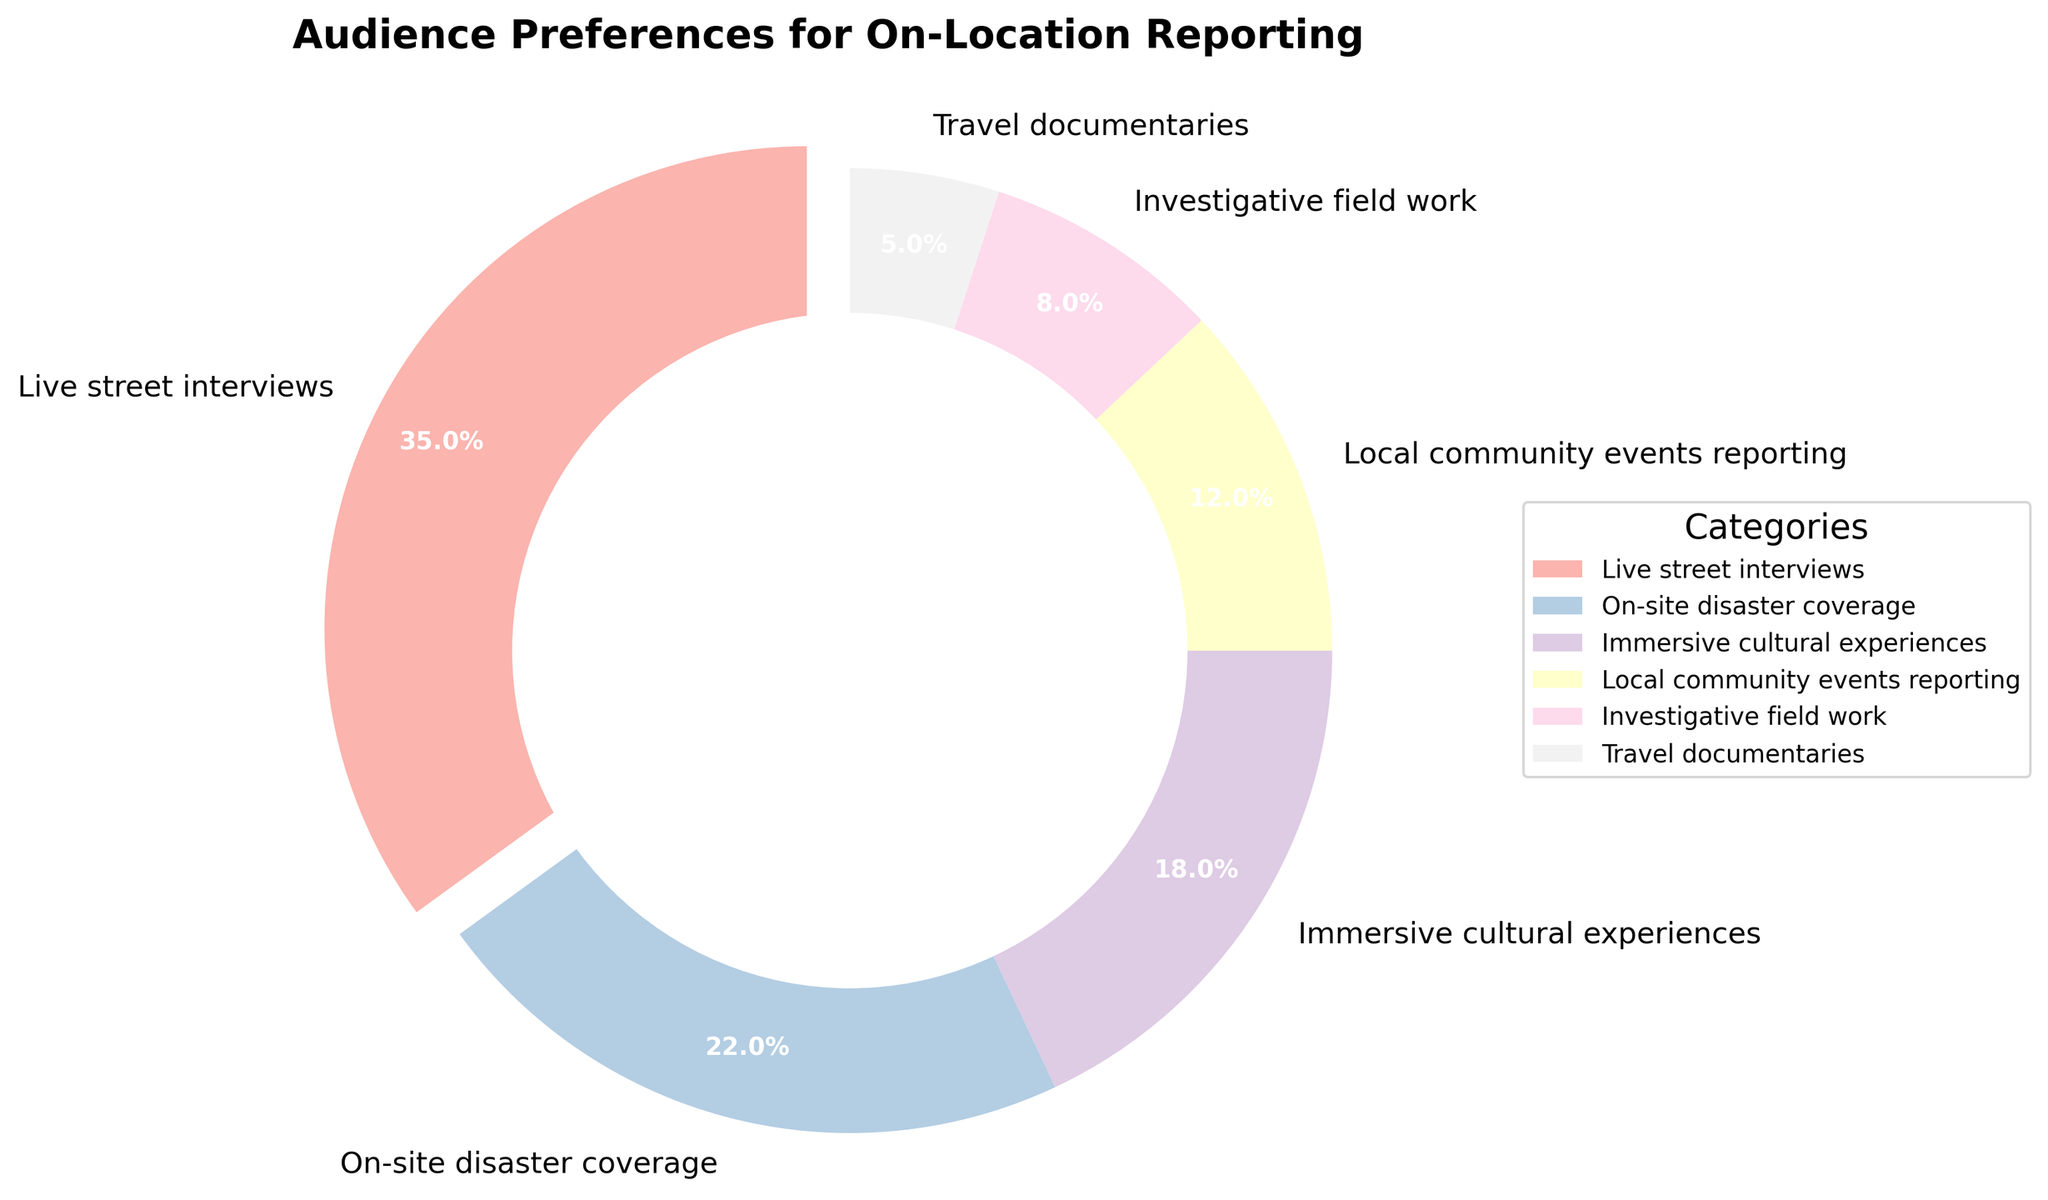Which category has the highest audience preference? The largest segment in the pie chart is the one denoted by the boldest wedge, which represents "Live street interviews." The percentage label also confirms that this category has 35%.
Answer: Live street interviews Which two categories together constitute more than half of the total audience preferences? The "Live street interviews" segment at 35% and the "On-site disaster coverage" segment at 22% together add up to 57%, which is more than half of the total 100%.
Answer: Live street interviews and On-site disaster coverage How much more preferred is "Immersive cultural experiences" compared to "Travel documentaries"? "Immersive cultural experiences" has a preference of 18%, while "Travel documentaries" has 5%. The difference between them is 18% - 5% = 13%.
Answer: 13% Which segment is visually highlighted in the pie chart and why? The "Live street interviews" segment appears visually highlighted with a slight offset (exploded view), indicating that it is emphasized as the category with the highest preference, at 35%.
Answer: Live street interviews, because it has the highest preference What is the combined percentage of the least three preferred categories? The three least preferred categories are "Local community events reporting" (12%), "Investigative field work" (8%), and "Travel documentaries" (5%). Combined, they add up to 12% + 8% + 5% = 25%.
Answer: 25% Which category does the darkest color in the pie chart represent? The pie chart uses a color gradient, and typically, the darkest color represents the category with the lowest percentage. In this chart, the darkest color corresponds to "Travel documentaries," which has 5%.
Answer: Travel documentaries How does the preference for "Live street interviews" compare with the combined preferences for "Investigative field work" and "Travel documentaries"? "Live street interviews" has a preference of 35%. The combined preferences for "Investigative field work" (8%) and "Travel documentaries" (5%) are 8% + 5% = 13%. Thus, "Live street interviews" is preferred 22% more (35% - 13% = 22%).
Answer: 22% more How much more popular is "Local community events reporting" compared to "Travel documentaries"? "Local community events reporting" has a preference of 12%, while "Travel documentaries" has 5%. The difference is 12% - 5% = 7%.
Answer: 7% What proportion of the pie chart is made up by "On-site disaster coverage" and "Immersive cultural experiences"? The segments for "On-site disaster coverage" and "Immersive cultural experiences" are 22% and 18%, respectively. Combined, they make up 22% + 18% = 40% of the pie chart.
Answer: 40% What is the visual representation technique used to emphasize the category with the highest audience preference? The category with the highest audience preference, "Live street interviews" at 35%, is emphasized using an exploded view (slightly offset from the pie chart).
Answer: Exploded view (slightly offset) 